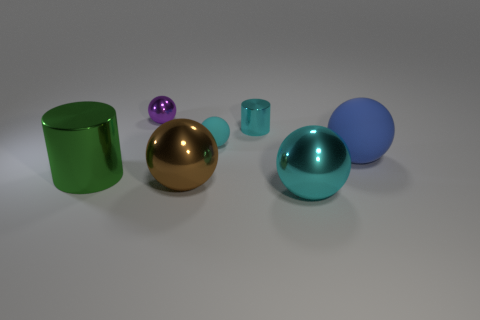There is another object that is the same material as the blue thing; what is its shape? The object sharing the same reflective material properties as the blue sphere is a golden sphere. It exhibits a similar level of glossiness and specular highlights, characteristic of a smooth and shiny surface. 